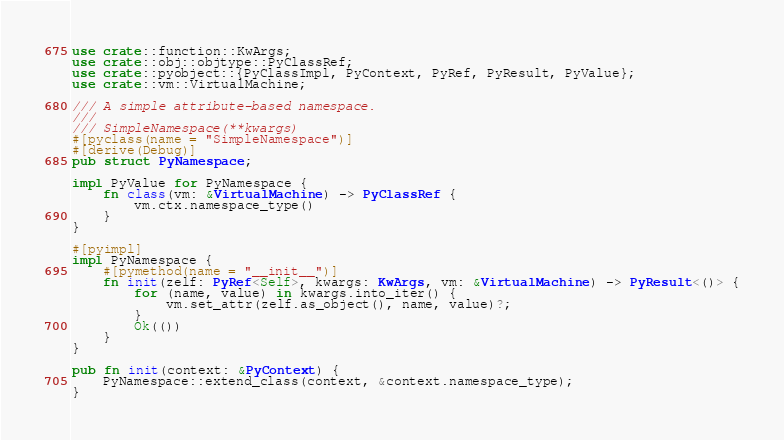<code> <loc_0><loc_0><loc_500><loc_500><_Rust_>use crate::function::KwArgs;
use crate::obj::objtype::PyClassRef;
use crate::pyobject::{PyClassImpl, PyContext, PyRef, PyResult, PyValue};
use crate::vm::VirtualMachine;

/// A simple attribute-based namespace.
///
/// SimpleNamespace(**kwargs)
#[pyclass(name = "SimpleNamespace")]
#[derive(Debug)]
pub struct PyNamespace;

impl PyValue for PyNamespace {
    fn class(vm: &VirtualMachine) -> PyClassRef {
        vm.ctx.namespace_type()
    }
}

#[pyimpl]
impl PyNamespace {
    #[pymethod(name = "__init__")]
    fn init(zelf: PyRef<Self>, kwargs: KwArgs, vm: &VirtualMachine) -> PyResult<()> {
        for (name, value) in kwargs.into_iter() {
            vm.set_attr(zelf.as_object(), name, value)?;
        }
        Ok(())
    }
}

pub fn init(context: &PyContext) {
    PyNamespace::extend_class(context, &context.namespace_type);
}
</code> 